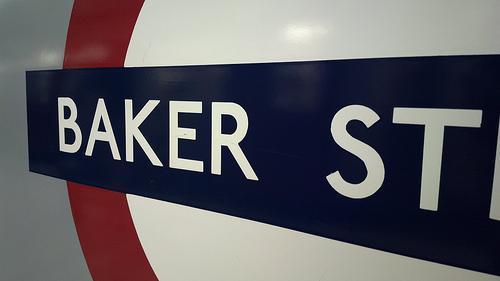How many letters of text are shown?
Give a very brief answer. 7. 